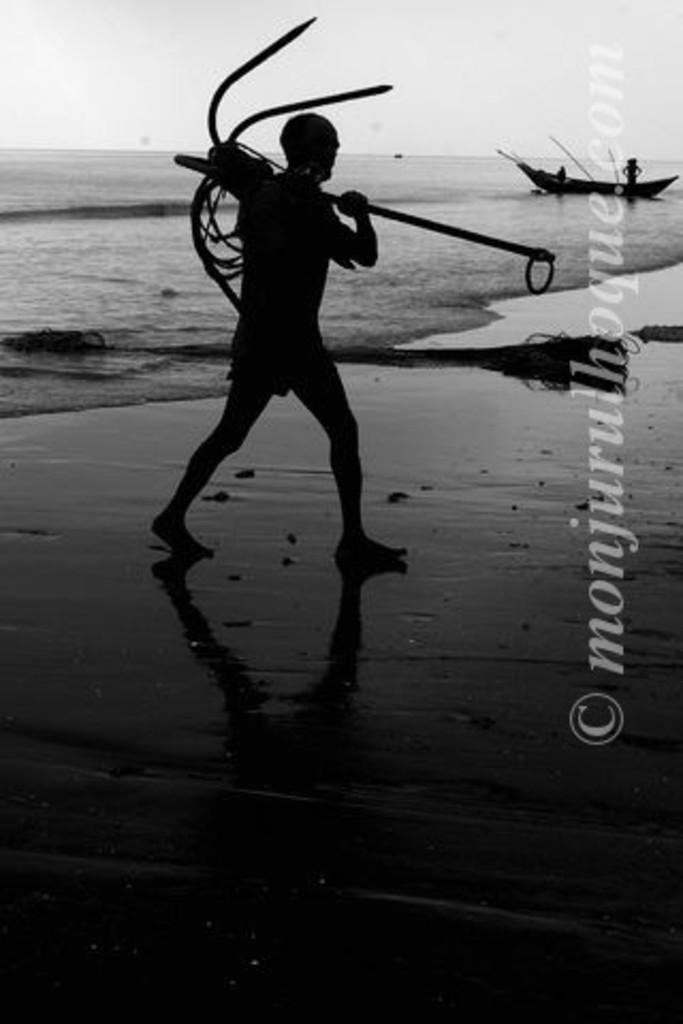<image>
Give a short and clear explanation of the subsequent image. the name Monjuru starts off a long word that is copyrighted 